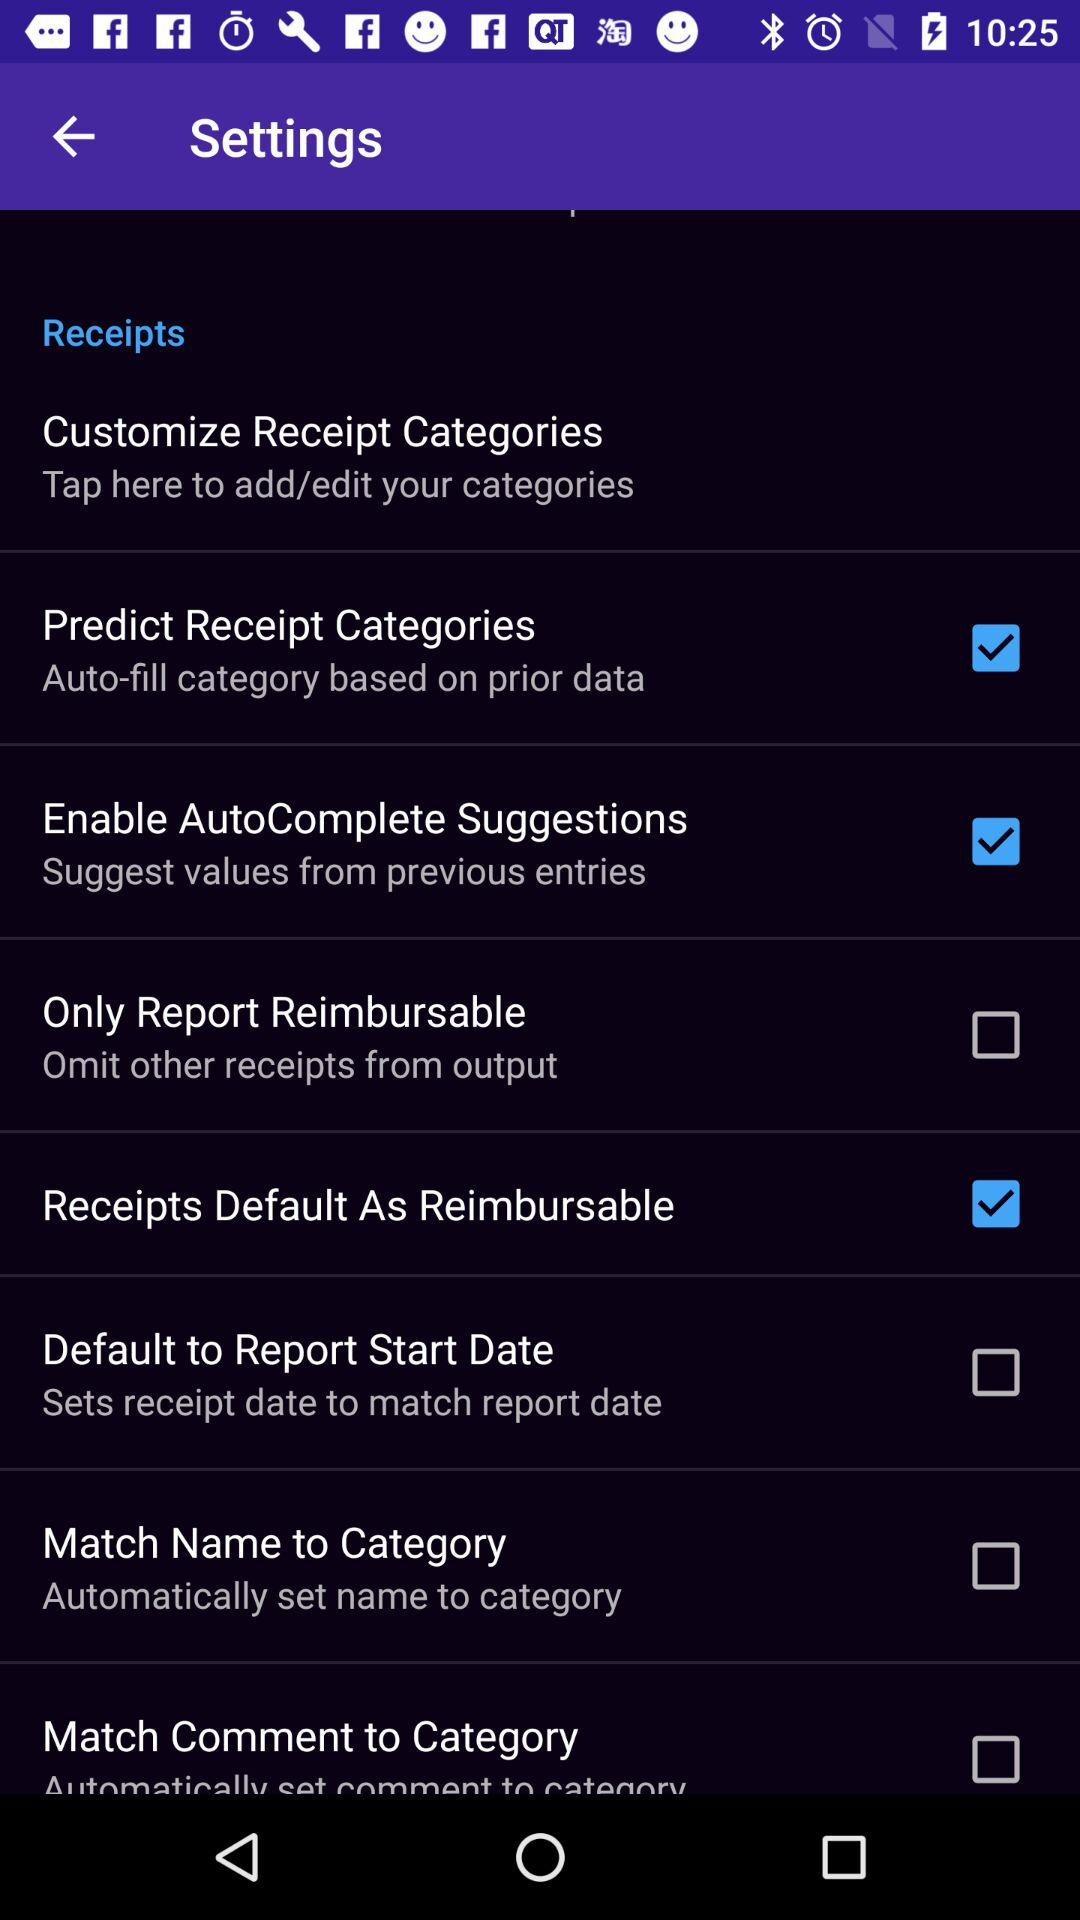What's the status of "Predict Receipt Categories"? The status is "on". 